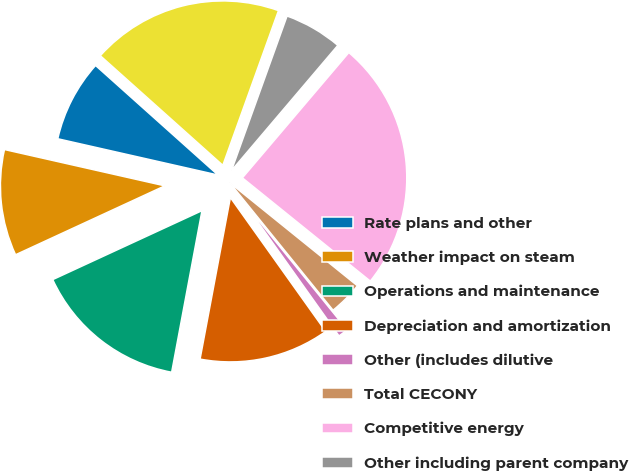<chart> <loc_0><loc_0><loc_500><loc_500><pie_chart><fcel>Rate plans and other<fcel>Weather impact on steam<fcel>Operations and maintenance<fcel>Depreciation and amortization<fcel>Other (includes dilutive<fcel>Total CECONY<fcel>Competitive energy<fcel>Other including parent company<fcel>Total variations<nl><fcel>8.07%<fcel>10.43%<fcel>15.16%<fcel>12.8%<fcel>0.99%<fcel>3.35%<fcel>24.6%<fcel>5.71%<fcel>18.88%<nl></chart> 